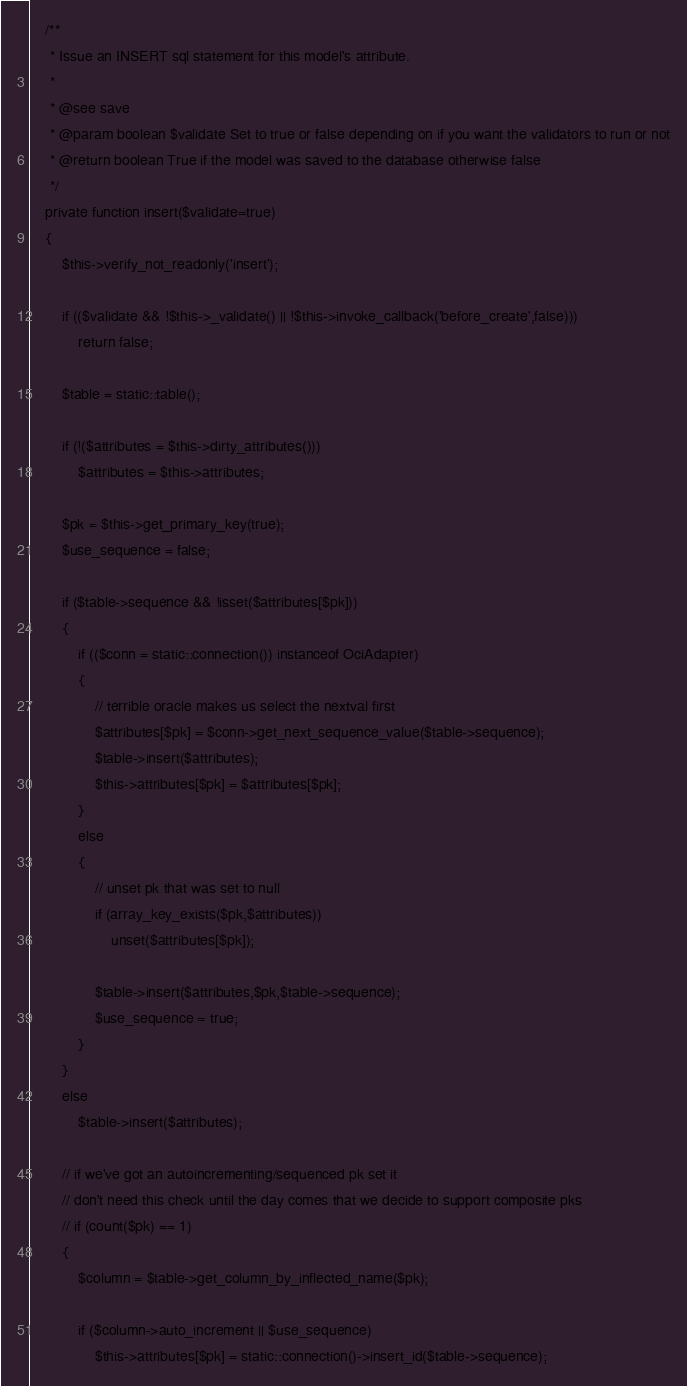Convert code to text. <code><loc_0><loc_0><loc_500><loc_500><_PHP_>
	/**
	 * Issue an INSERT sql statement for this model's attribute.
	 *
	 * @see save
	 * @param boolean $validate Set to true or false depending on if you want the validators to run or not
	 * @return boolean True if the model was saved to the database otherwise false
	 */
	private function insert($validate=true)
	{
		$this->verify_not_readonly('insert');

		if (($validate && !$this->_validate() || !$this->invoke_callback('before_create',false)))
			return false;

		$table = static::table();

		if (!($attributes = $this->dirty_attributes()))
			$attributes = $this->attributes;

		$pk = $this->get_primary_key(true);
		$use_sequence = false;

		if ($table->sequence && !isset($attributes[$pk]))
		{
			if (($conn = static::connection()) instanceof OciAdapter)
			{
				// terrible oracle makes us select the nextval first
				$attributes[$pk] = $conn->get_next_sequence_value($table->sequence);
				$table->insert($attributes);
				$this->attributes[$pk] = $attributes[$pk];
			}
			else
			{
				// unset pk that was set to null
				if (array_key_exists($pk,$attributes))
					unset($attributes[$pk]);

				$table->insert($attributes,$pk,$table->sequence);
				$use_sequence = true;
			}
		}
		else
			$table->insert($attributes);

		// if we've got an autoincrementing/sequenced pk set it
		// don't need this check until the day comes that we decide to support composite pks
		// if (count($pk) == 1)
		{
			$column = $table->get_column_by_inflected_name($pk);

			if ($column->auto_increment || $use_sequence)
				$this->attributes[$pk] = static::connection()->insert_id($table->sequence);</code> 